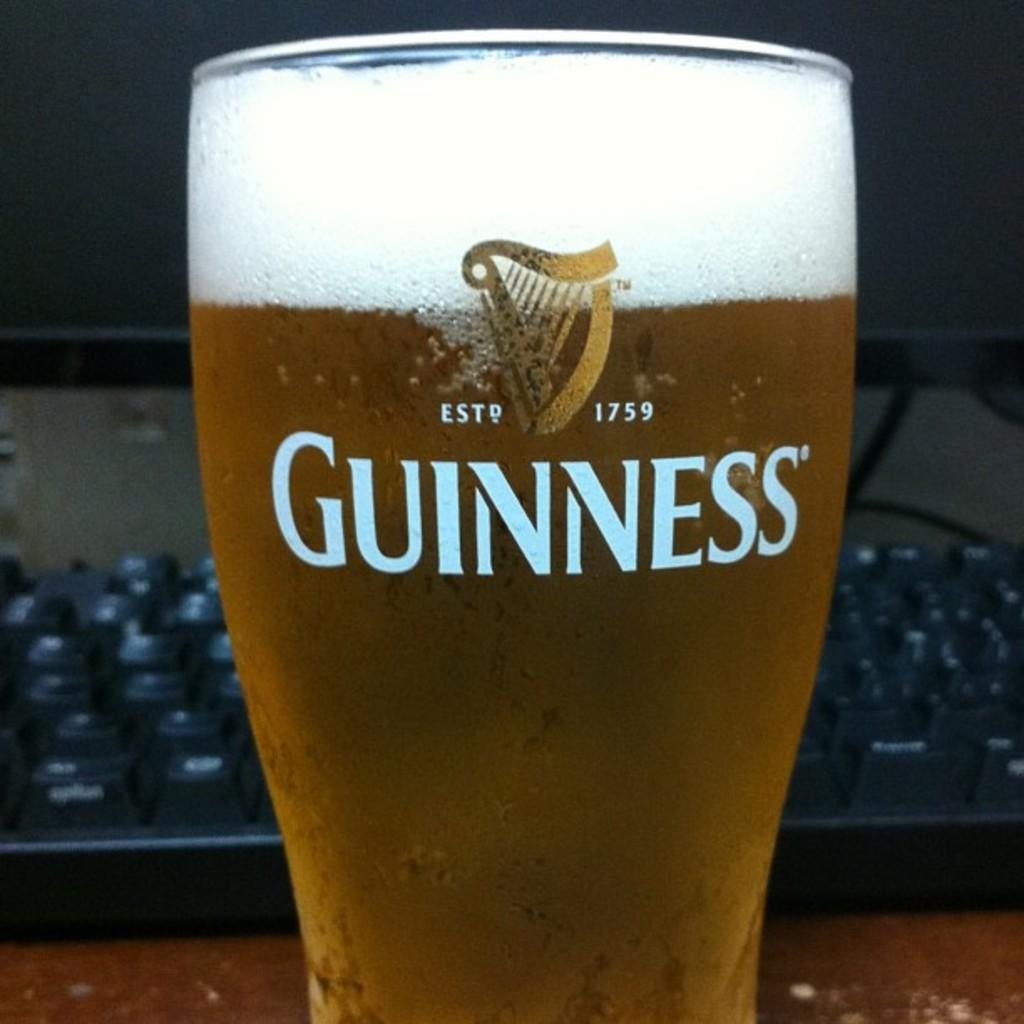What is in the foreground of the image? There is a glass in the foreground of the image. What is inside the glass? The glass contains a drink. What can be seen in the background of the image? There is a computer and a keyboard in the background of the image. How many snails are crawling on the keyboard in the image? There are no snails present in the image; the keyboard is not shown with any snails. 